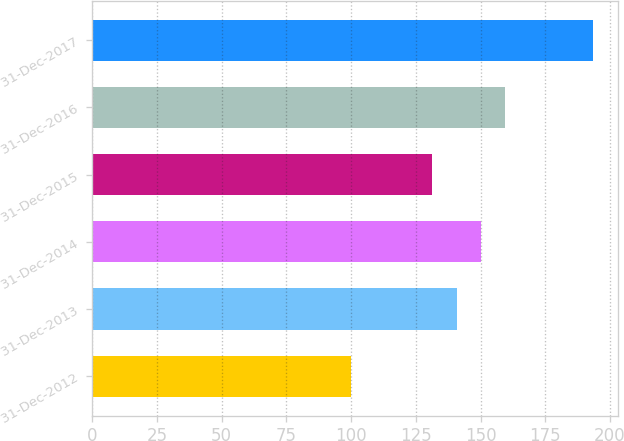Convert chart. <chart><loc_0><loc_0><loc_500><loc_500><bar_chart><fcel>31-Dec-2012<fcel>31-Dec-2013<fcel>31-Dec-2014<fcel>31-Dec-2015<fcel>31-Dec-2016<fcel>31-Dec-2017<nl><fcel>100<fcel>140.75<fcel>150.1<fcel>131.4<fcel>159.45<fcel>193.5<nl></chart> 